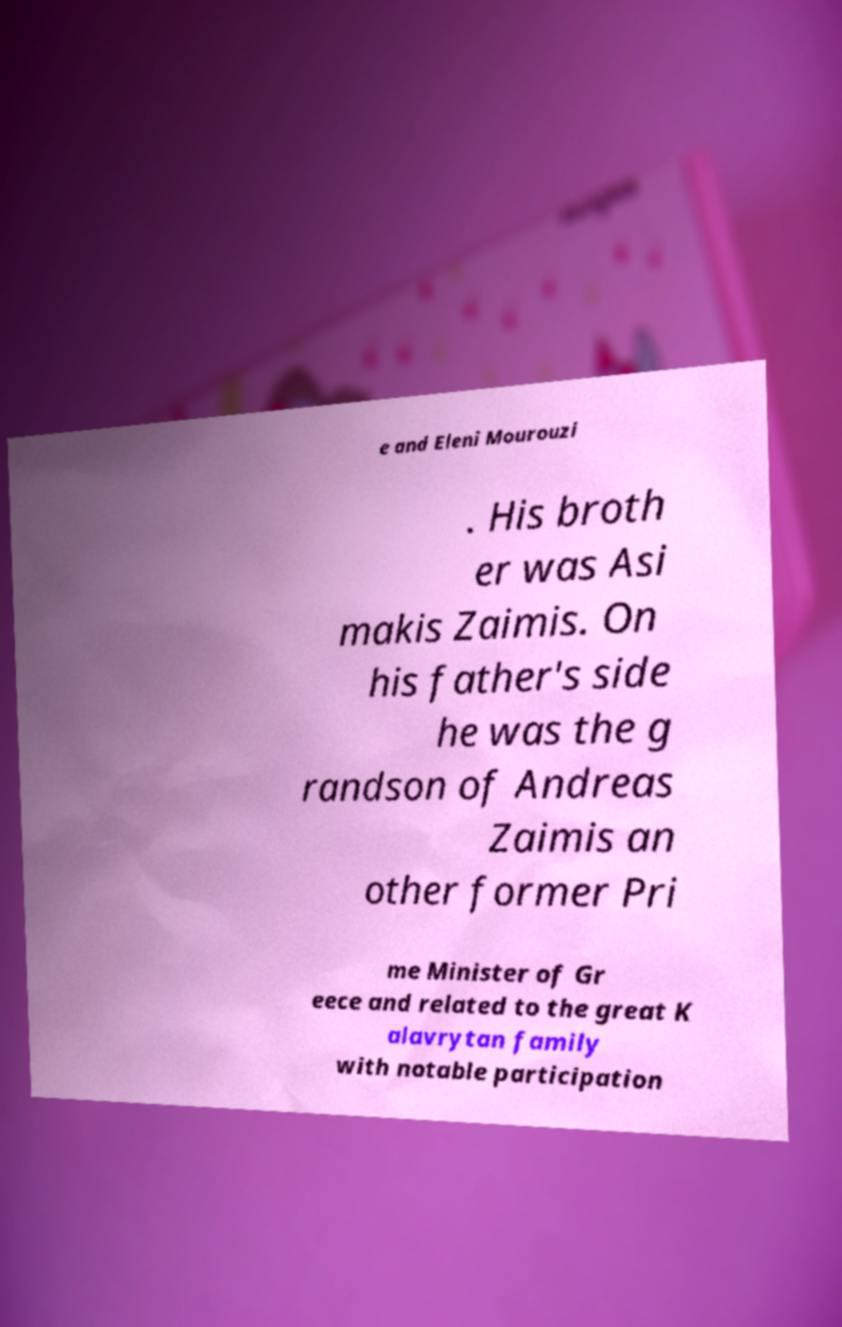Can you accurately transcribe the text from the provided image for me? e and Eleni Mourouzi . His broth er was Asi makis Zaimis. On his father's side he was the g randson of Andreas Zaimis an other former Pri me Minister of Gr eece and related to the great K alavrytan family with notable participation 